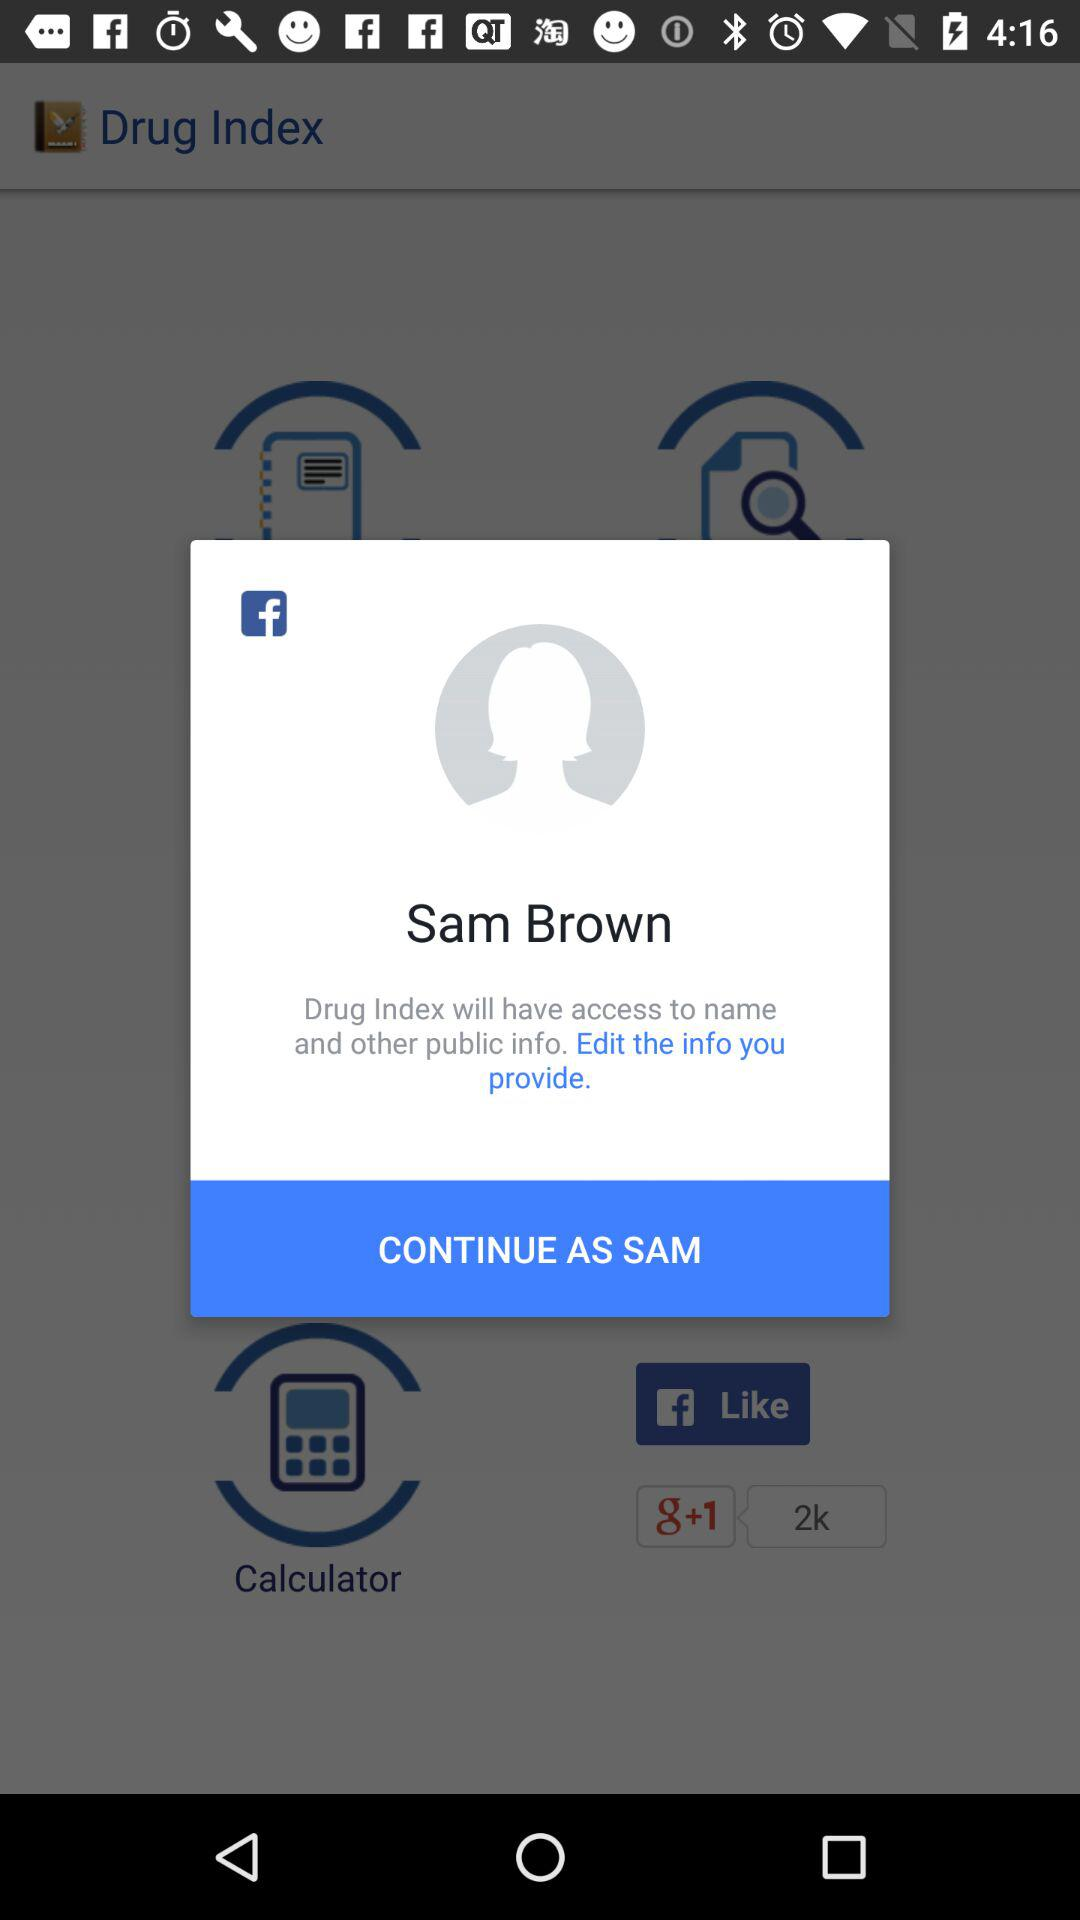What is the login name? The login name is Sam Brown. 